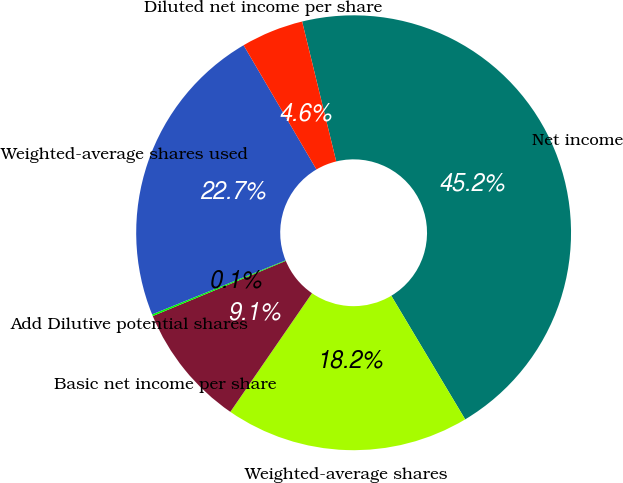Convert chart. <chart><loc_0><loc_0><loc_500><loc_500><pie_chart><fcel>Net income<fcel>Weighted-average shares<fcel>Basic net income per share<fcel>Add Dilutive potential shares<fcel>Weighted-average shares used<fcel>Diluted net income per share<nl><fcel>45.23%<fcel>18.17%<fcel>9.15%<fcel>0.13%<fcel>22.68%<fcel>4.64%<nl></chart> 